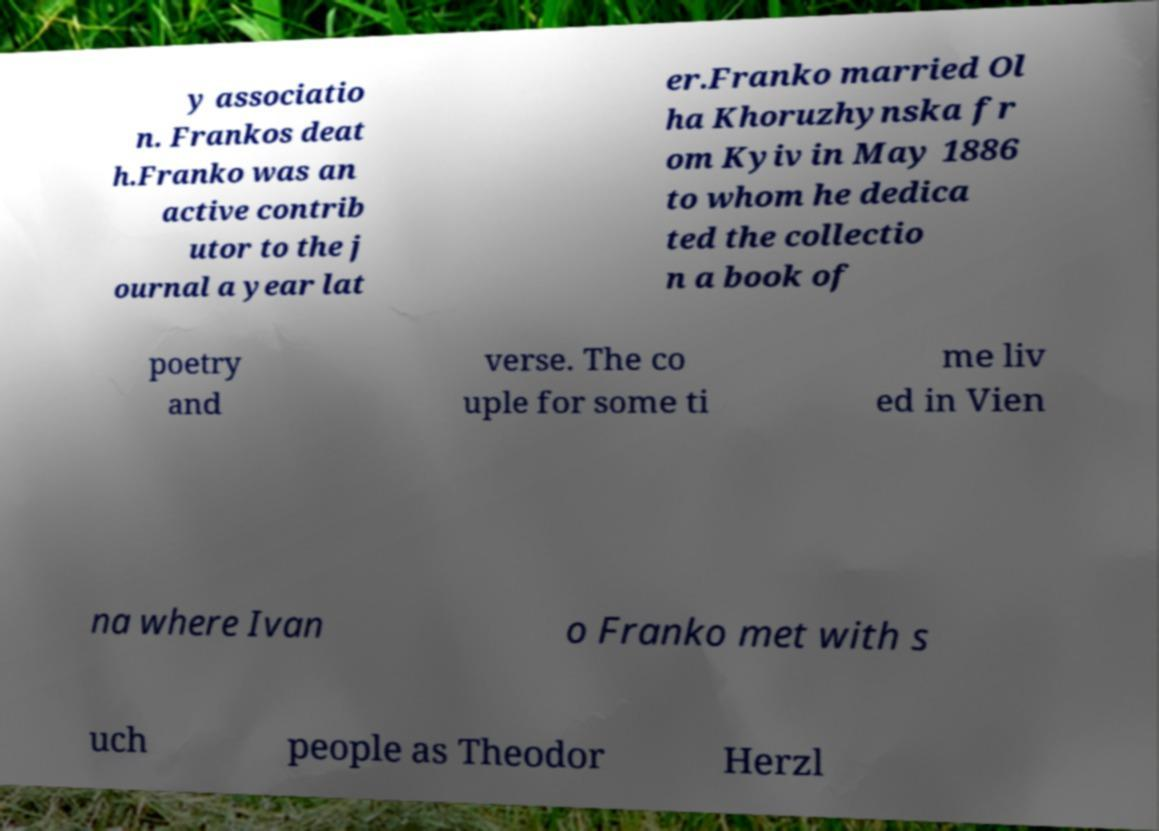Can you accurately transcribe the text from the provided image for me? y associatio n. Frankos deat h.Franko was an active contrib utor to the j ournal a year lat er.Franko married Ol ha Khoruzhynska fr om Kyiv in May 1886 to whom he dedica ted the collectio n a book of poetry and verse. The co uple for some ti me liv ed in Vien na where Ivan o Franko met with s uch people as Theodor Herzl 